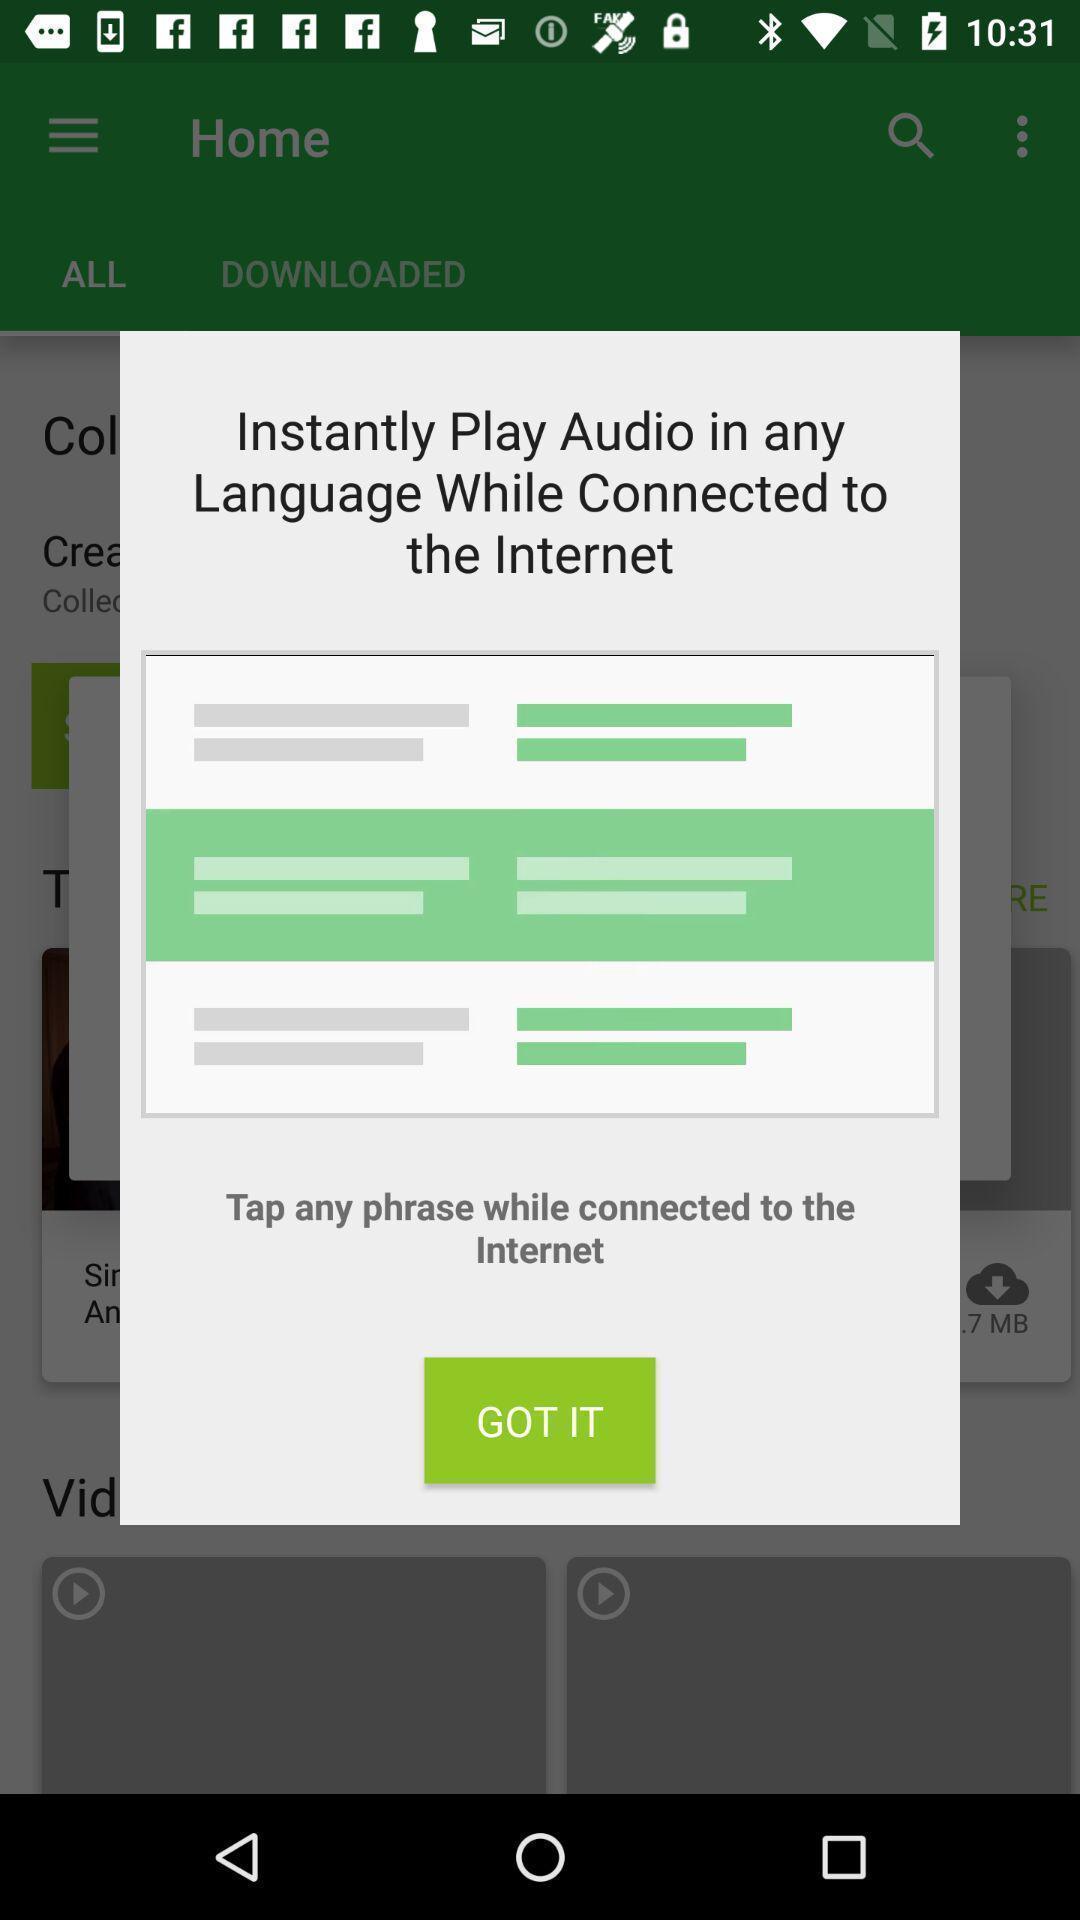Describe the content in this image. Pop-up showing to tap any phrase. 